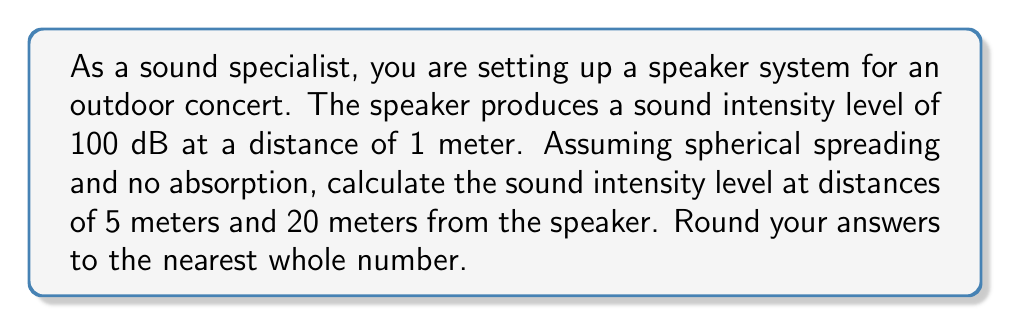Show me your answer to this math problem. To solve this problem, we'll use the inverse square law for sound intensity and the equation for sound intensity level.

1. The inverse square law states that sound intensity is inversely proportional to the square of the distance from the source:

   $$ I_2 = I_1 \cdot \left(\frac{r_1}{r_2}\right)^2 $$

   where $I$ is the sound intensity and $r$ is the distance from the source.

2. The equation for sound intensity level (SIL) in decibels is:

   $$ SIL = 10 \log_{10}\left(\frac{I}{I_0}\right) $$

   where $I_0$ is the reference intensity (typically $10^{-12}$ W/m²).

3. We're given the SIL at 1 meter is 100 dB. We don't need to know the actual intensity, just the relative change.

4. For 5 meters:
   $$ SIL_5 = SIL_1 - 20 \log_{10}\left(\frac{r_2}{r_1}\right) $$
   $$ SIL_5 = 100 - 20 \log_{10}\left(\frac{5}{1}\right) $$
   $$ SIL_5 = 100 - 20 \cdot 0.699 $$
   $$ SIL_5 = 100 - 13.98 = 86.02 \text{ dB} $$

5. For 20 meters:
   $$ SIL_{20} = 100 - 20 \log_{10}\left(\frac{20}{1}\right) $$
   $$ SIL_{20} = 100 - 20 \cdot 1.301 $$
   $$ SIL_{20} = 100 - 26.02 = 73.98 \text{ dB} $$

Rounding to the nearest whole number:
At 5 meters: 86 dB
At 20 meters: 74 dB
Answer: At 5 meters: 86 dB
At 20 meters: 74 dB 